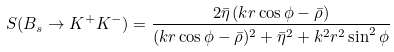<formula> <loc_0><loc_0><loc_500><loc_500>S ( B _ { s } \to K ^ { + } K ^ { - } ) = \frac { 2 \bar { \eta } \, ( k r \cos \phi - \bar { \rho } ) } { ( k r \cos \phi - \bar { \rho } ) ^ { 2 } + \bar { \eta } ^ { 2 } + k ^ { 2 } r ^ { 2 } \sin ^ { 2 } \phi }</formula> 